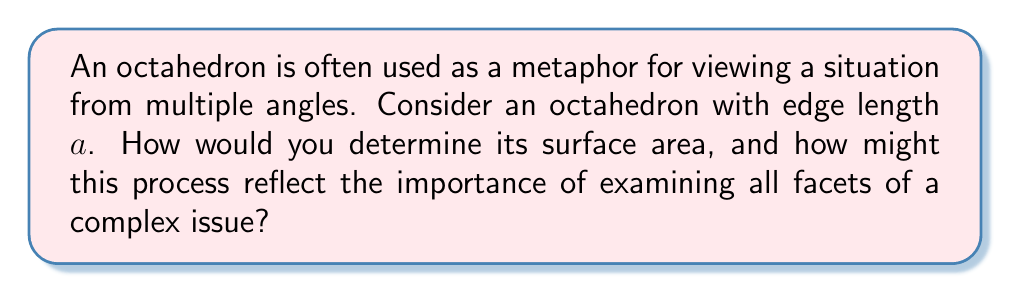Solve this math problem. Let's approach this step-by-step, considering each facet of the octahedron:

1) First, we need to understand the structure of an octahedron:
   - An octahedron has 8 congruent equilateral triangular faces.
   - All edges of an octahedron are equal in length.

2) To find the surface area, we need to:
   a) Calculate the area of one triangular face
   b) Multiply this area by 8 (the number of faces)

3) For an equilateral triangle with side length $a$, the area is given by:

   $$A_{\text{triangle}} = \frac{\sqrt{3}}{4}a^2$$

4) Deriving this formula:
   - Height of the equilateral triangle: $h = a\frac{\sqrt{3}}{2}$
   - Area = $\frac{1}{2} \times base \times height = \frac{1}{2} \times a \times a\frac{\sqrt{3}}{2} = \frac{\sqrt{3}}{4}a^2$

5) The surface area of the octahedron is then:

   $$SA_{\text{octahedron}} = 8 \times A_{\text{triangle}} = 8 \times \frac{\sqrt{3}}{4}a^2 = 2\sqrt{3}a^2$$

This process mirrors the importance of examining all aspects of a complex issue:
- Just as we considered all 8 faces to get the full surface area, in communication, we must consider all perspectives to fully understand a situation.
- The symmetry of the octahedron reminds us that all viewpoints are equally valuable.
- The step-by-step approach demonstrates how breaking down complex problems into manageable parts can lead to comprehensive solutions.

[asy]
import three;

size(200);
currentprojection=perspective(6,3,2);

triple A=(1,1,1), B=(1,-1,-1), C=(-1,1,-1), D=(-1,-1,1);

draw(A--B--C--D--A);
draw(A--C);
draw(B--D);

dot(A);
dot(B);
dot(C);
dot(D);

label("A",A,N);
label("B",B,S);
label("C",C,W);
label("D",D,E);
[/asy]
Answer: The surface area of an octahedron with edge length $a$ is $2\sqrt{3}a^2$ square units. 